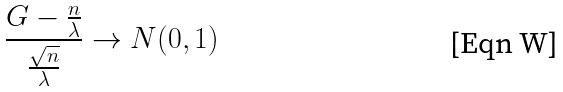<formula> <loc_0><loc_0><loc_500><loc_500>\frac { G - \frac { n } { \lambda } } { \frac { \sqrt { n } } { \lambda } } \rightarrow N ( 0 , 1 )</formula> 